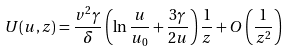<formula> <loc_0><loc_0><loc_500><loc_500>U ( u , z ) = \frac { v ^ { 2 } \gamma } { \delta } \left ( \ln \frac { u } { u _ { 0 } } + \frac { 3 \gamma } { 2 u } \right ) \frac { 1 } { z } + O \left ( \frac { 1 } { z ^ { 2 } } \right )</formula> 